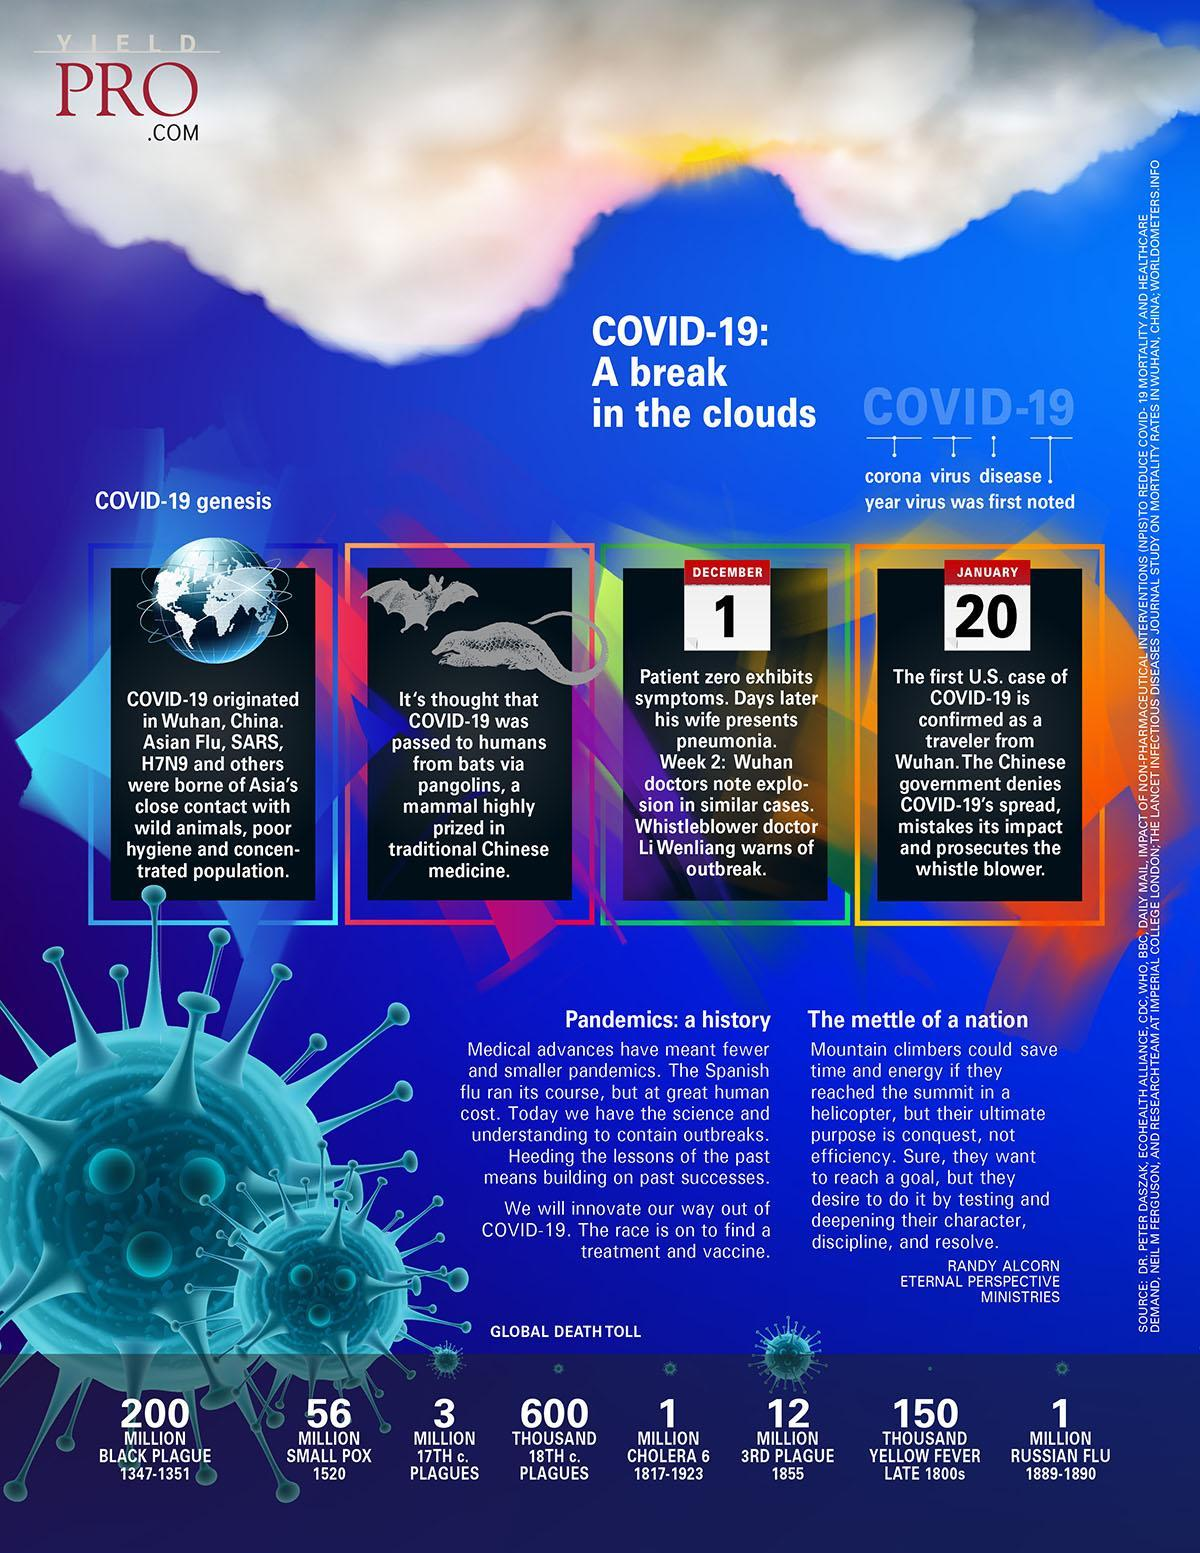Where was the first case of COVID-19 reported?
Answer the question with a short phrase. Wuhan, China During which time period, the black plague pandemic happened? 1347-1351 During which time period, the Russian flu pandemic happened? 1889-1890 When did the third plague pandemic started? 1855 When did the smallpox epidemic start? 1520 Which two animals are believed to be the source of COVID-19 virus in China? bats, pangolins 